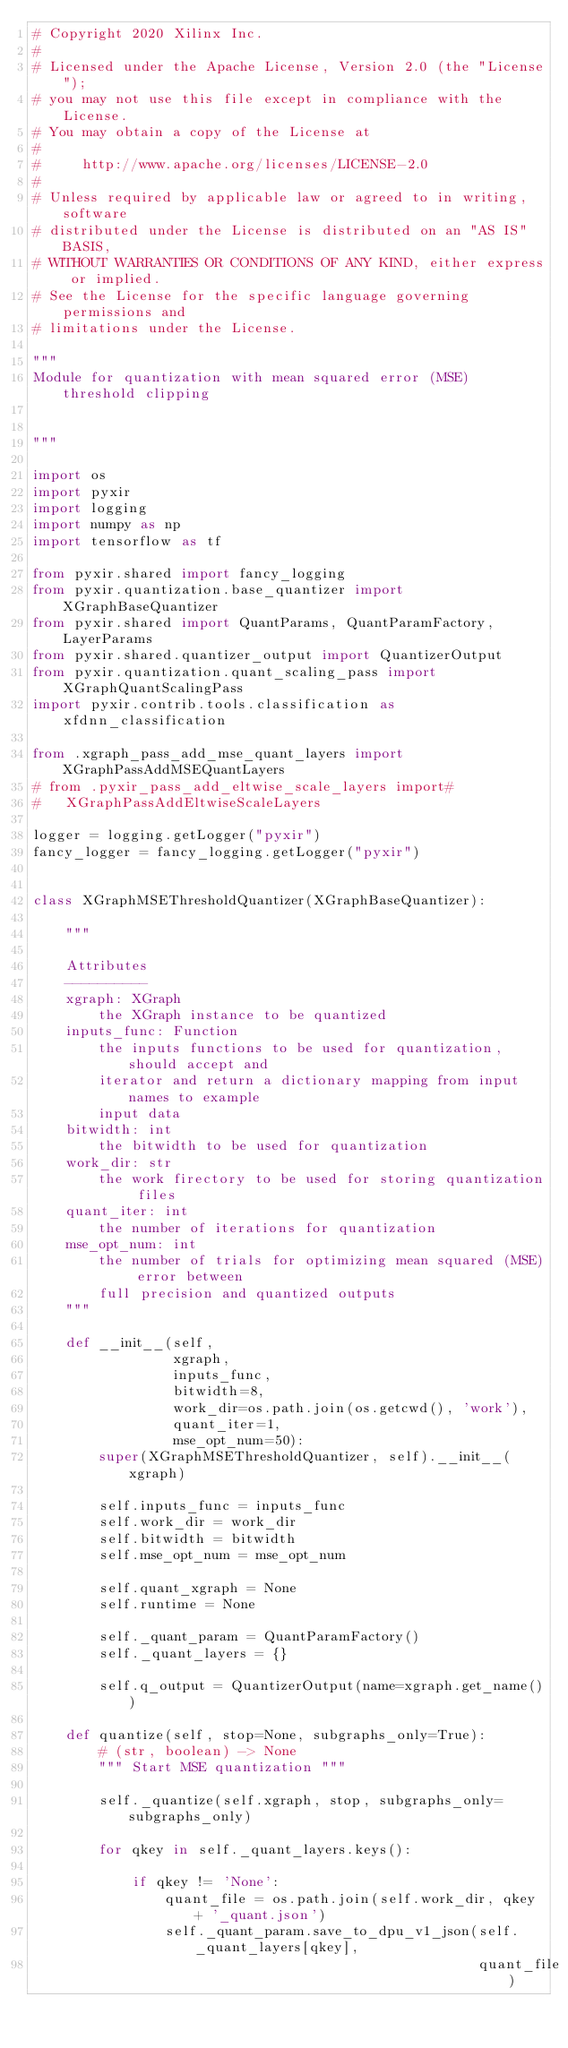Convert code to text. <code><loc_0><loc_0><loc_500><loc_500><_Python_># Copyright 2020 Xilinx Inc.
#
# Licensed under the Apache License, Version 2.0 (the "License");
# you may not use this file except in compliance with the License.
# You may obtain a copy of the License at
#
#     http://www.apache.org/licenses/LICENSE-2.0
#
# Unless required by applicable law or agreed to in writing, software
# distributed under the License is distributed on an "AS IS" BASIS,
# WITHOUT WARRANTIES OR CONDITIONS OF ANY KIND, either express or implied.
# See the License for the specific language governing permissions and
# limitations under the License.

"""
Module for quantization with mean squared error (MSE) threshold clipping


"""

import os
import pyxir
import logging
import numpy as np
import tensorflow as tf

from pyxir.shared import fancy_logging
from pyxir.quantization.base_quantizer import XGraphBaseQuantizer
from pyxir.shared import QuantParams, QuantParamFactory, LayerParams
from pyxir.shared.quantizer_output import QuantizerOutput
from pyxir.quantization.quant_scaling_pass import XGraphQuantScalingPass
import pyxir.contrib.tools.classification as xfdnn_classification

from .xgraph_pass_add_mse_quant_layers import XGraphPassAddMSEQuantLayers
# from .pyxir_pass_add_eltwise_scale_layers import#
#   XGraphPassAddEltwiseScaleLayers

logger = logging.getLogger("pyxir")
fancy_logger = fancy_logging.getLogger("pyxir")


class XGraphMSEThresholdQuantizer(XGraphBaseQuantizer):

    """

    Attributes
    ----------
    xgraph: XGraph
        the XGraph instance to be quantized
    inputs_func: Function
        the inputs functions to be used for quantization, should accept and
        iterator and return a dictionary mapping from input names to example
        input data
    bitwidth: int
        the bitwidth to be used for quantization
    work_dir: str
        the work firectory to be used for storing quantization files
    quant_iter: int
        the number of iterations for quantization
    mse_opt_num: int
        the number of trials for optimizing mean squared (MSE) error between
        full precision and quantized outputs
    """

    def __init__(self,
                 xgraph,
                 inputs_func,
                 bitwidth=8,
                 work_dir=os.path.join(os.getcwd(), 'work'),
                 quant_iter=1,
                 mse_opt_num=50):
        super(XGraphMSEThresholdQuantizer, self).__init__(xgraph)

        self.inputs_func = inputs_func
        self.work_dir = work_dir
        self.bitwidth = bitwidth
        self.mse_opt_num = mse_opt_num

        self.quant_xgraph = None
        self.runtime = None

        self._quant_param = QuantParamFactory()
        self._quant_layers = {}

        self.q_output = QuantizerOutput(name=xgraph.get_name())

    def quantize(self, stop=None, subgraphs_only=True):
        # (str, boolean) -> None
        """ Start MSE quantization """

        self._quantize(self.xgraph, stop, subgraphs_only=subgraphs_only)

        for qkey in self._quant_layers.keys():

            if qkey != 'None':
                quant_file = os.path.join(self.work_dir, qkey + '_quant.json')
                self._quant_param.save_to_dpu_v1_json(self._quant_layers[qkey],
                                                      quant_file)
</code> 